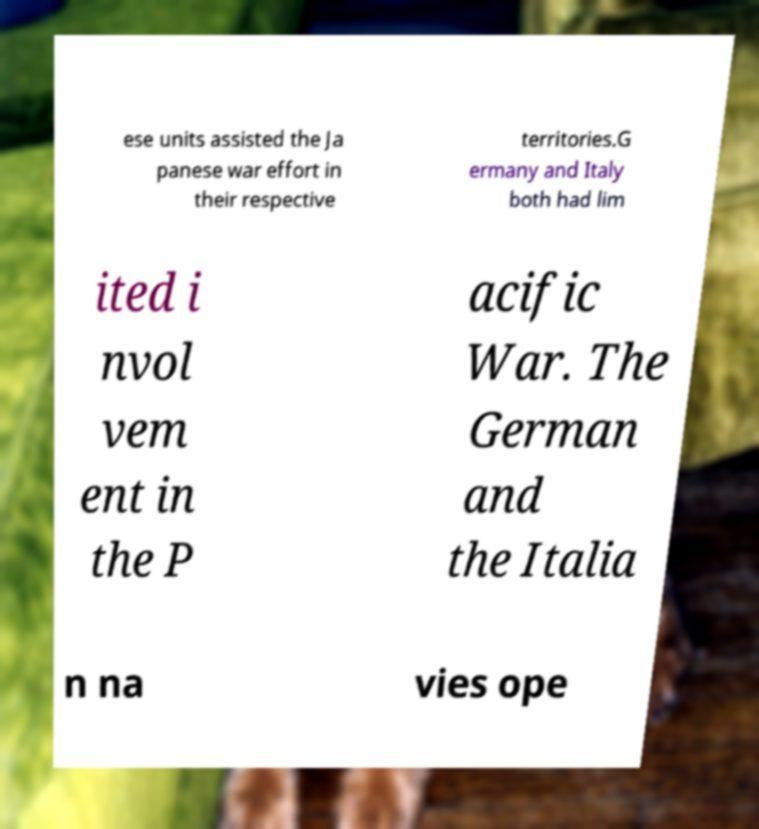Please read and relay the text visible in this image. What does it say? ese units assisted the Ja panese war effort in their respective territories.G ermany and Italy both had lim ited i nvol vem ent in the P acific War. The German and the Italia n na vies ope 